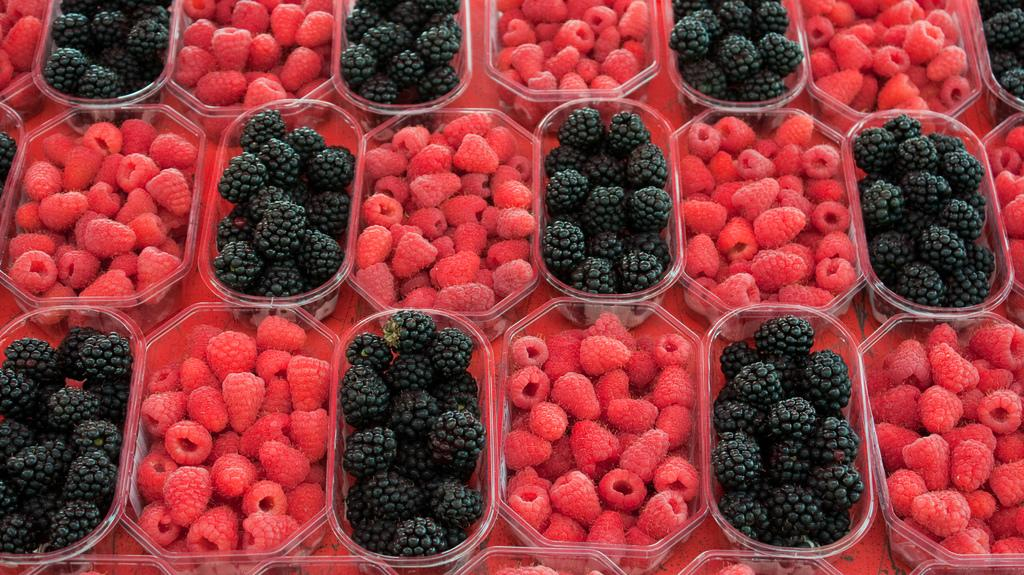What type of fruit is present in the image? The image contains berries. What colors can be seen on the berries? The berries are black and red in color. How are the berries stored or organized in the image? The berries are kept in boxes. What type of oil is being used to preserve the berries in the image? There is no oil present in the image; the berries are kept in boxes. 